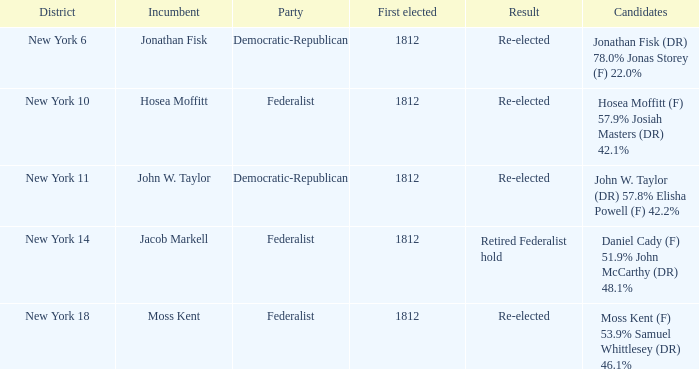Who was the first elected candidate with hosea moffitt receiving 57.9% and josiah masters getting 42.1% of the votes? 1812.0. 